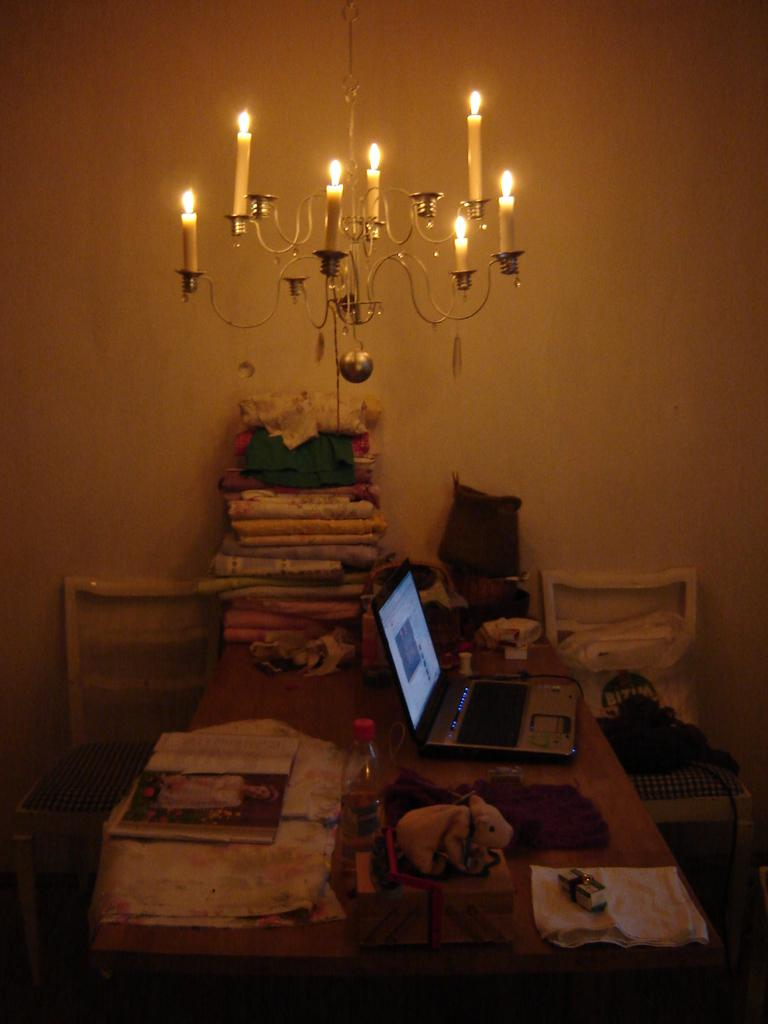What type of furniture is present in the image? There is a table in the image. What items can be seen on the table? There are clothes, a book, a laptop, a bottle, and a toy on the table. Are there any additional objects in the image? Yes, there are candles in the image. What can be seen in the background of the image? There is a wall in the background of the image. What type of bun is being used as a bookmark in the book? There is no bun present in the image, and the book does not have a bun being used as a bookmark. 